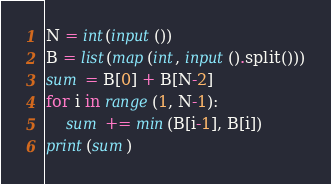Convert code to text. <code><loc_0><loc_0><loc_500><loc_500><_Python_>N = int(input())
B = list(map(int, input().split()))
sum = B[0] + B[N-2]
for i in range(1, N-1):
    sum += min(B[i-1], B[i])
print(sum)</code> 